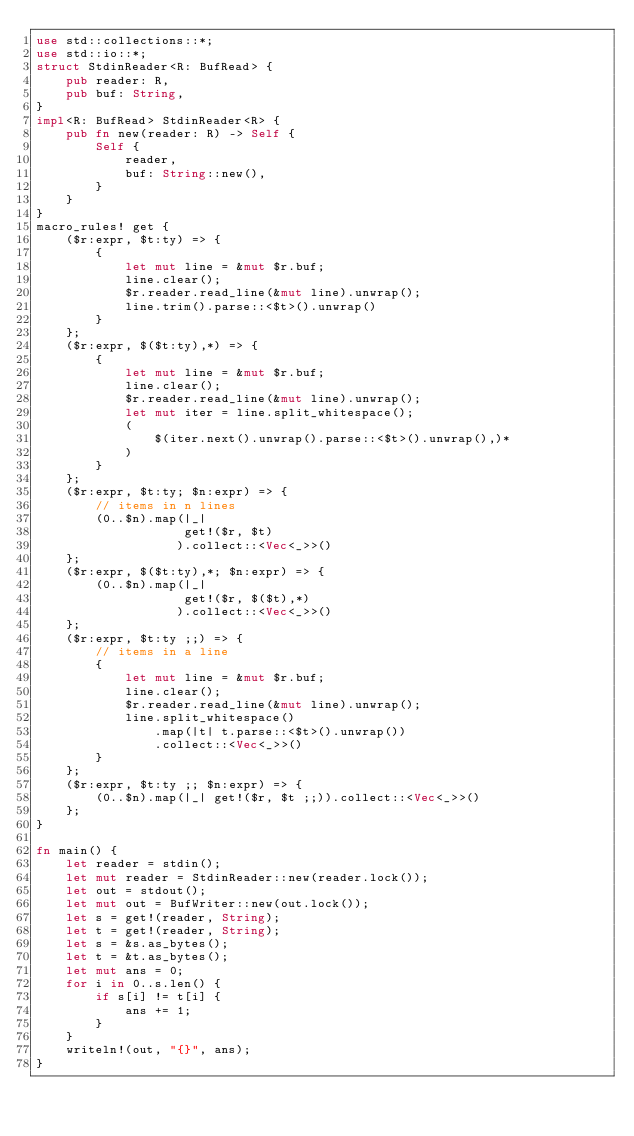Convert code to text. <code><loc_0><loc_0><loc_500><loc_500><_Rust_>use std::collections::*;
use std::io::*;
struct StdinReader<R: BufRead> {
    pub reader: R,
    pub buf: String,
}
impl<R: BufRead> StdinReader<R> {
    pub fn new(reader: R) -> Self {
        Self {
            reader,
            buf: String::new(),
        }
    }
}
macro_rules! get {
    ($r:expr, $t:ty) => {
        {
            let mut line = &mut $r.buf;
            line.clear();
            $r.reader.read_line(&mut line).unwrap();
            line.trim().parse::<$t>().unwrap()
        }
    };
    ($r:expr, $($t:ty),*) => {
        {
            let mut line = &mut $r.buf;
            line.clear();
            $r.reader.read_line(&mut line).unwrap();
            let mut iter = line.split_whitespace();
            (
                $(iter.next().unwrap().parse::<$t>().unwrap(),)*
            )
        }
    };
    ($r:expr, $t:ty; $n:expr) => {
        // items in n lines
        (0..$n).map(|_|
                    get!($r, $t)
                   ).collect::<Vec<_>>()
    };
    ($r:expr, $($t:ty),*; $n:expr) => {
        (0..$n).map(|_|
                    get!($r, $($t),*)
                   ).collect::<Vec<_>>()
    };
    ($r:expr, $t:ty ;;) => {
        // items in a line
        {
            let mut line = &mut $r.buf;
            line.clear();
            $r.reader.read_line(&mut line).unwrap();
            line.split_whitespace()
                .map(|t| t.parse::<$t>().unwrap())
                .collect::<Vec<_>>()
        }
    };
    ($r:expr, $t:ty ;; $n:expr) => {
        (0..$n).map(|_| get!($r, $t ;;)).collect::<Vec<_>>()
    };
}

fn main() {
    let reader = stdin();
    let mut reader = StdinReader::new(reader.lock());
    let out = stdout();
    let mut out = BufWriter::new(out.lock());
    let s = get!(reader, String);
    let t = get!(reader, String);
    let s = &s.as_bytes();
    let t = &t.as_bytes();
    let mut ans = 0;
    for i in 0..s.len() {
        if s[i] != t[i] {
            ans += 1;
        }
    }
    writeln!(out, "{}", ans);
}
</code> 